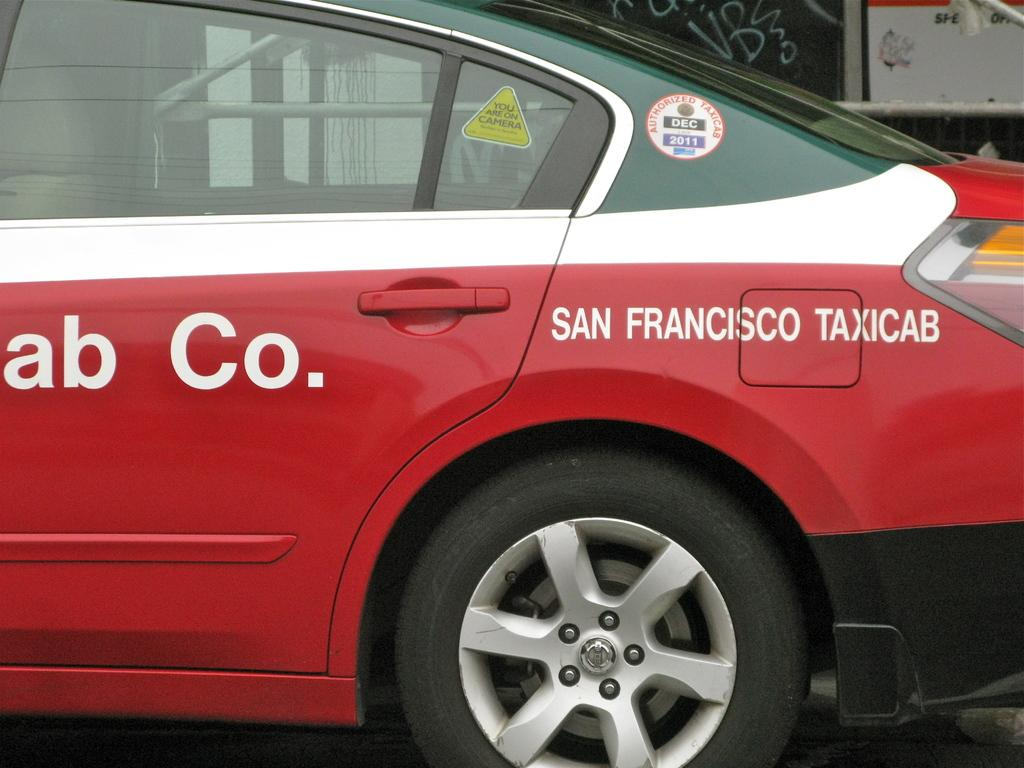What is the main subject of the image? The main subject of the image is a car. What colors can be seen on the car? The car has green, white, and red colors. Are there any words or letters on the car? Yes, there is writing on the car. How many boats are visible in the image? There are no boats present in the image; it features a car with writing on it. What type of yam is being used as a decoration on the car? There is no yam present in the image, as it features a car with writing on it. 